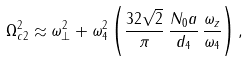Convert formula to latex. <formula><loc_0><loc_0><loc_500><loc_500>\Omega _ { c 2 } ^ { 2 } \approx \omega _ { \perp } ^ { 2 } + \omega _ { 4 } ^ { 2 } \left ( \frac { 3 2 \sqrt { 2 } } { \pi } \, \frac { N _ { 0 } a } { d _ { 4 } } \, \frac { \omega _ { z } } { \omega _ { 4 } } \right ) ,</formula> 